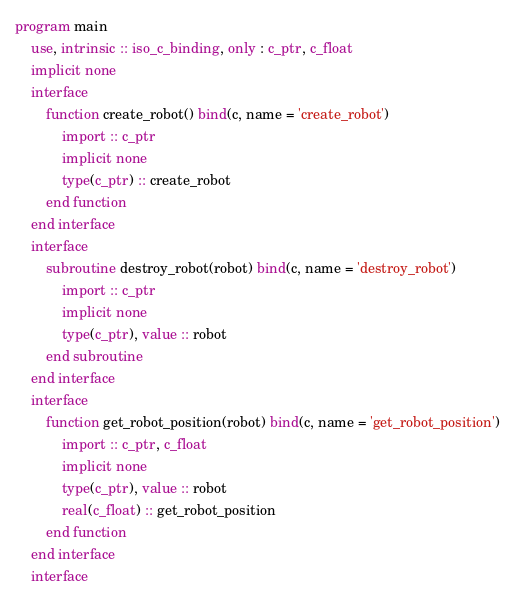<code> <loc_0><loc_0><loc_500><loc_500><_FORTRAN_>program main
    use, intrinsic :: iso_c_binding, only : c_ptr, c_float
    implicit none
    interface
        function create_robot() bind(c, name = 'create_robot')
            import :: c_ptr
            implicit none
            type(c_ptr) :: create_robot
        end function
    end interface
    interface
        subroutine destroy_robot(robot) bind(c, name = 'destroy_robot')
            import :: c_ptr
            implicit none
            type(c_ptr), value :: robot
        end subroutine
    end interface
    interface
        function get_robot_position(robot) bind(c, name = 'get_robot_position')
            import :: c_ptr, c_float
            implicit none
            type(c_ptr), value :: robot
            real(c_float) :: get_robot_position
        end function
    end interface
    interface</code> 